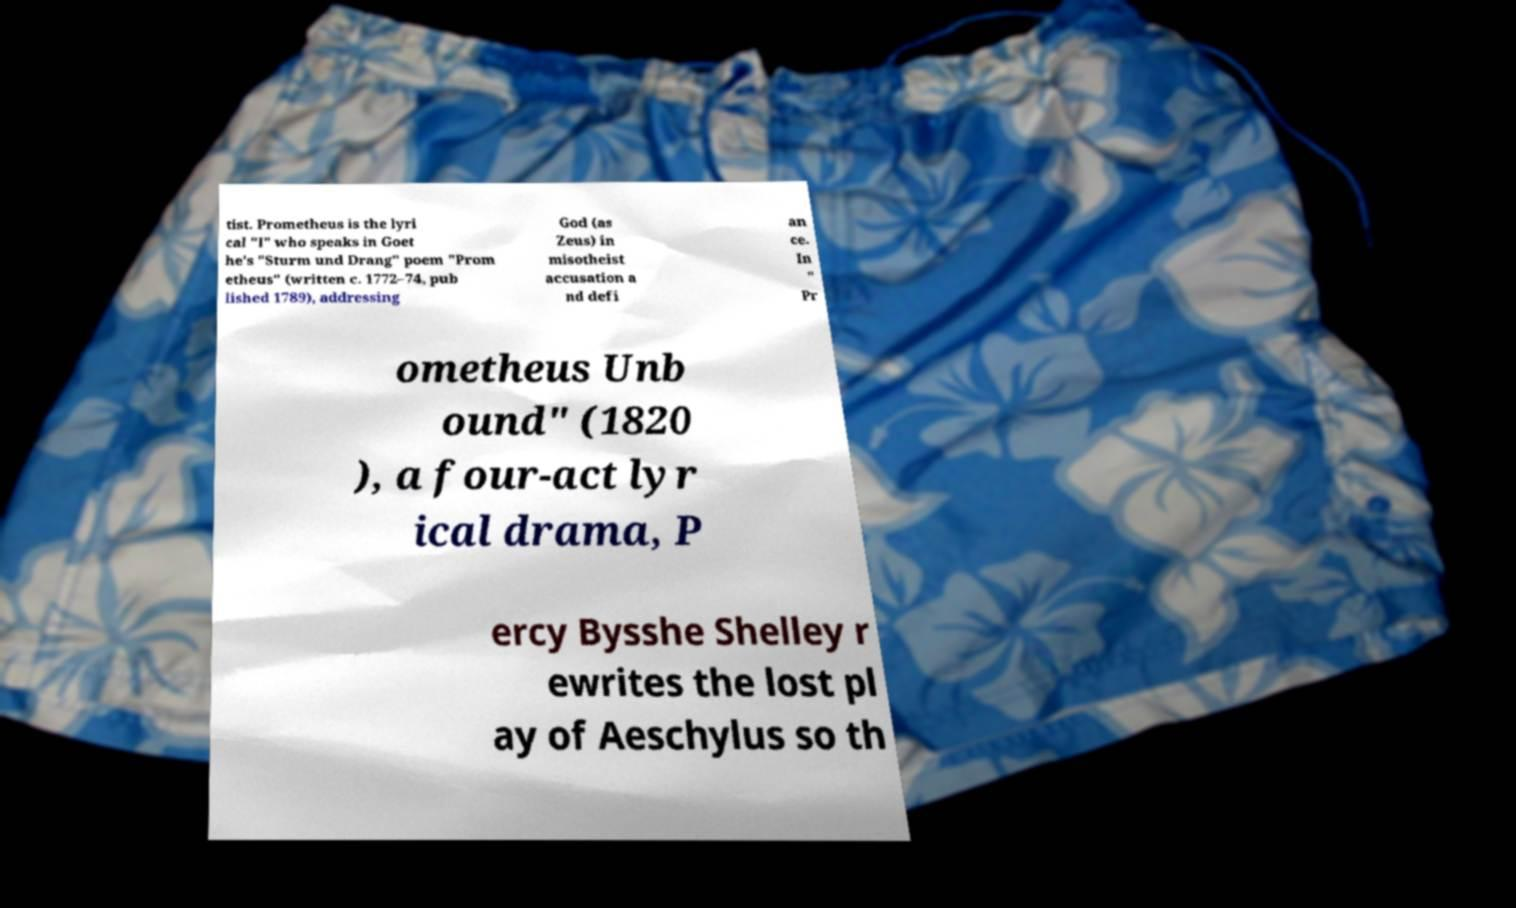For documentation purposes, I need the text within this image transcribed. Could you provide that? tist. Prometheus is the lyri cal "I" who speaks in Goet he's "Sturm und Drang" poem "Prom etheus" (written c. 1772–74, pub lished 1789), addressing God (as Zeus) in misotheist accusation a nd defi an ce. In " Pr ometheus Unb ound" (1820 ), a four-act lyr ical drama, P ercy Bysshe Shelley r ewrites the lost pl ay of Aeschylus so th 